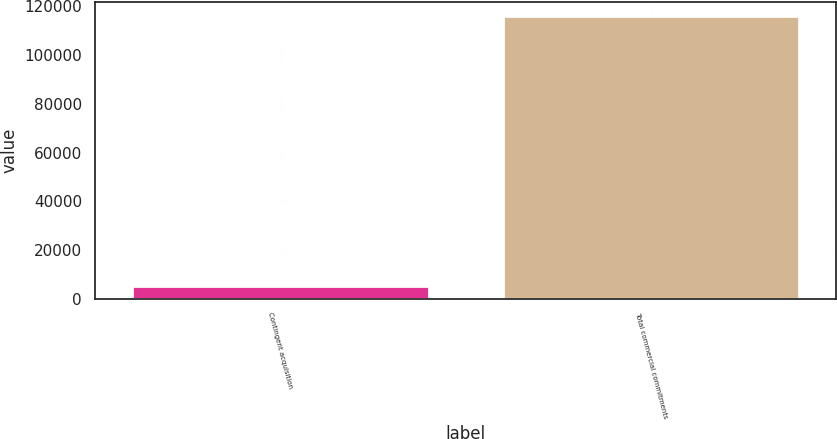Convert chart to OTSL. <chart><loc_0><loc_0><loc_500><loc_500><bar_chart><fcel>Contingent acquisition<fcel>Total commercial commitments<nl><fcel>5062<fcel>115936<nl></chart> 